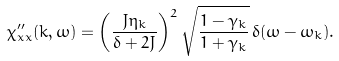Convert formula to latex. <formula><loc_0><loc_0><loc_500><loc_500>\chi _ { x x } ^ { \prime \prime } ( { k } , \omega ) = \left ( \frac { J \eta _ { k } } { \delta + 2 J } \right ) ^ { 2 } \sqrt { \frac { 1 - \gamma _ { k } } { 1 + \gamma _ { k } } } \, \delta ( \omega - \omega _ { k } ) .</formula> 